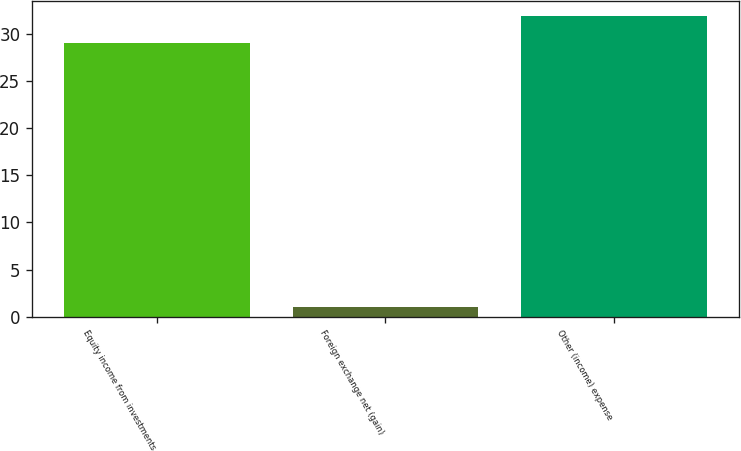<chart> <loc_0><loc_0><loc_500><loc_500><bar_chart><fcel>Equity income from investments<fcel>Foreign exchange net (gain)<fcel>Other (income) expense<nl><fcel>29<fcel>1<fcel>31.9<nl></chart> 